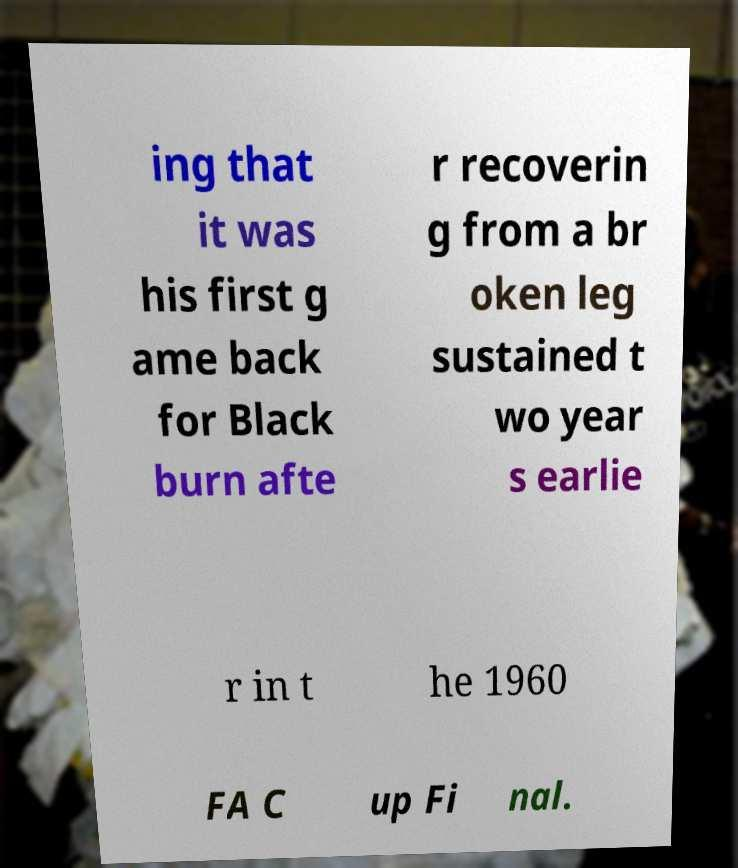What messages or text are displayed in this image? I need them in a readable, typed format. ing that it was his first g ame back for Black burn afte r recoverin g from a br oken leg sustained t wo year s earlie r in t he 1960 FA C up Fi nal. 